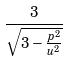Convert formula to latex. <formula><loc_0><loc_0><loc_500><loc_500>\frac { 3 } { \sqrt { 3 - \frac { p ^ { 2 } } { u ^ { 2 } } } }</formula> 